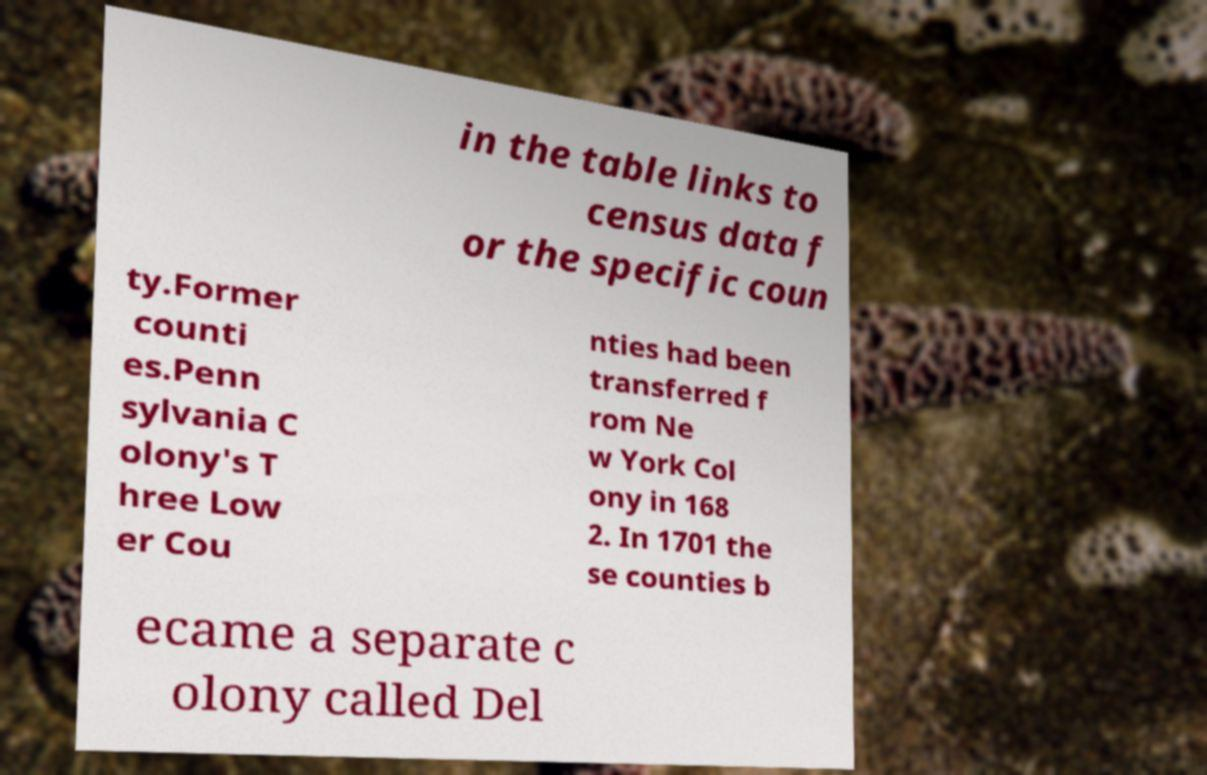Can you accurately transcribe the text from the provided image for me? in the table links to census data f or the specific coun ty.Former counti es.Penn sylvania C olony's T hree Low er Cou nties had been transferred f rom Ne w York Col ony in 168 2. In 1701 the se counties b ecame a separate c olony called Del 